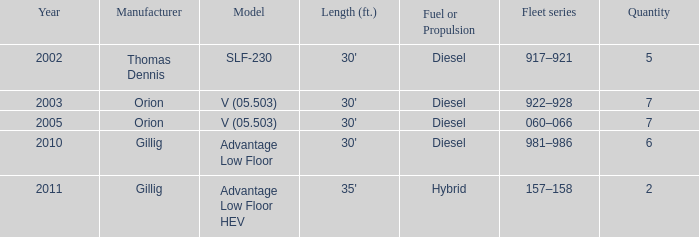Specify the series of fleets with a count of 917–921. 